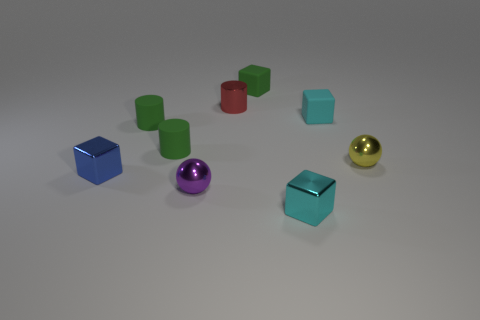Is there a tiny purple shiny thing that has the same shape as the tiny red object?
Your answer should be very brief. No. There is a tiny metal thing that is both behind the blue thing and to the left of the cyan rubber thing; what is its shape?
Offer a terse response. Cylinder. How many small blue things are made of the same material as the yellow thing?
Provide a short and direct response. 1. Is the number of small red objects in front of the blue metal cube less than the number of tiny blue matte cylinders?
Offer a very short reply. No. Are there any tiny cyan shiny cubes that are right of the tiny metal ball that is to the left of the small cyan metal cube?
Offer a very short reply. Yes. There is a small cyan block that is behind the metal block that is to the left of the sphere that is on the left side of the green rubber cube; what is it made of?
Give a very brief answer. Rubber. Are there the same number of cubes in front of the small red metallic cylinder and small green matte objects?
Make the answer very short. Yes. How many things are either small red balls or green cubes?
Your response must be concise. 1. What shape is the tiny cyan thing that is the same material as the purple object?
Make the answer very short. Cube. There is a cyan cube that is in front of the tiny purple sphere that is in front of the tiny yellow ball; what size is it?
Give a very brief answer. Small. 